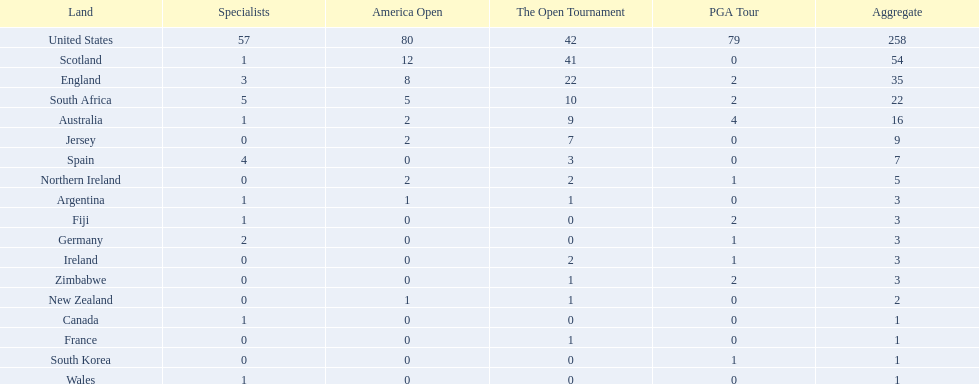Which african country has the least champion golfers according to this table? Zimbabwe. 